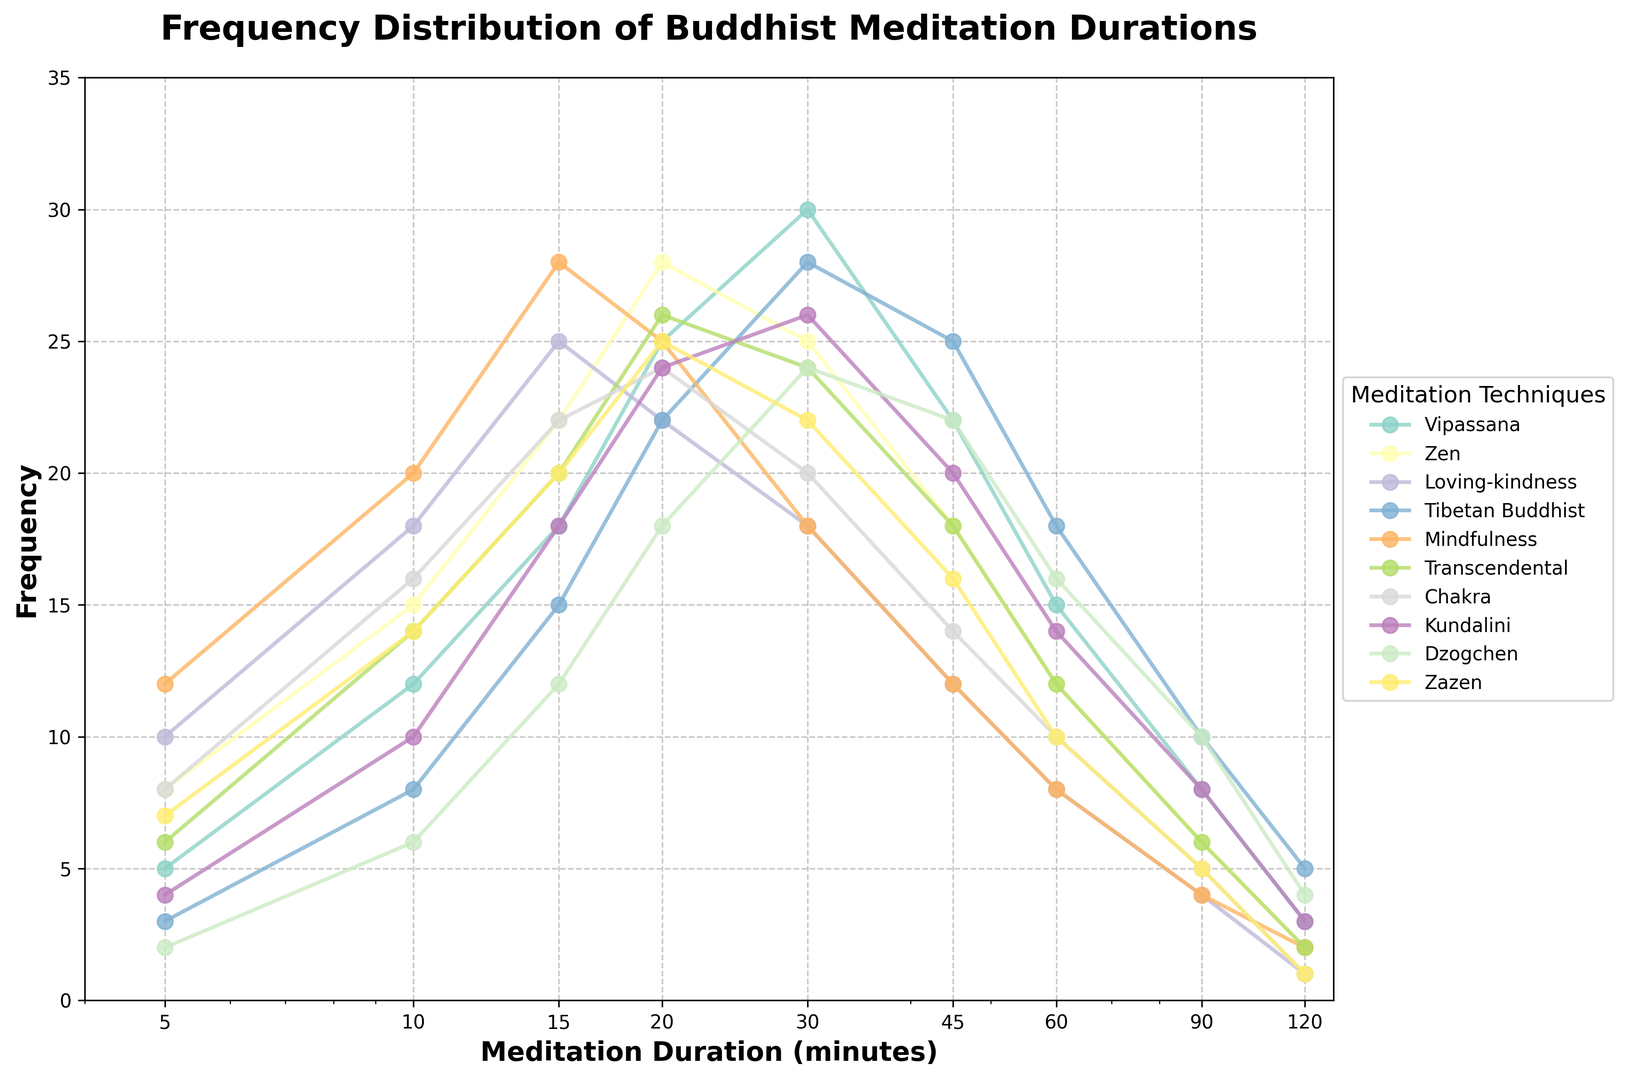What is the most frequent duration for Vipassana meditation? Reviewing the plot, look for the peak point on the Vipassana curve. The highest frequency for Vipassana is at 30 minutes with a frequency of 30.
Answer: 30 minutes Which meditation technique shows the highest frequency for a 120-minute session? Examine the 120-minute point on all curves. Tibetan Buddhist shows the highest frequency, with a frequency of 5 at 120 minutes.
Answer: Tibetan Buddhist What is the combined frequency of the 20-minute duration for Zen and Kundalini meditation? Identify the frequencies for Zen and Kundalini at the 20-minute mark. Zen has a frequency of 28 and Kundalini has 24. Adding them together, 28 + 24 = 52.
Answer: 52 Which meditation technique has the steepest drop in frequency from 30 minutes to 45 minutes? Look at the rate of decline between the 30-minute and 45-minute marks for all techniques. Vipassana drops from 30 to 22, giving a difference of 8, which is the steepest decline.
Answer: Vipassana Is there a technique where the frequency increases as the duration increases? Check each curve to see if any have frequencies that increase without decreasing. No technique displays a consistent increase in frequency with increasing duration.
Answer: No What is the average frequency for a 10-minute duration across all techniques? Add the frequencies of all techniques at 10 minutes and divide by the number of techniques (10). The frequencies are: 12, 15, 18, 8, 20, 14, 16, 10, 6, 14. Sum: 133. Average: 133/10 = 13.3.
Answer: 13.3 Which technique is least frequent for a 60-minute session? Identify the lowest frequency at the 60-minute mark. Dzogchen has the lowest frequency at 60 minutes with 16.
Answer: Dzogchen What is the proportional comparison between the frequencies of 45-minute and 5-minute sessions for the Mindfulness technique? Look at the Mindfulness frequencies for 45 minutes (12) and 5 minutes (12). The ratio is 12:12 which simplifies to 1:1.
Answer: 1:1 If you combine the frequencies of 90-minute sessions for Vipassana and Tibetan Buddhist, what percentage of the total combined frequency for all techniques at 90 minutes does this represent? Sum frequencies for Vipassana (8) and Tibetan Buddhist (10) at 90 minutes: 8 + 10 = 18. Total frequency for all techniques at 90 minutes: 8 + 6 + 4 + 10 + 4 + 6 + 5 + 8 + 10 + 5 = 66. Proportion: 18/66 ≈ 27.27%.
Answer: 27.27% 